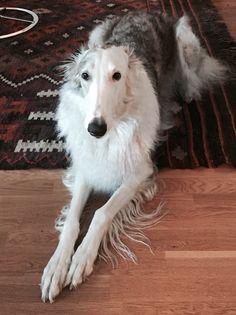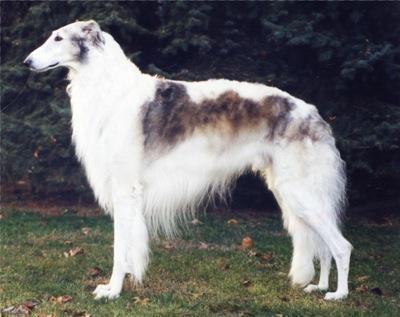The first image is the image on the left, the second image is the image on the right. Analyze the images presented: Is the assertion "At least one dog has its mouth open." valid? Answer yes or no. No. 